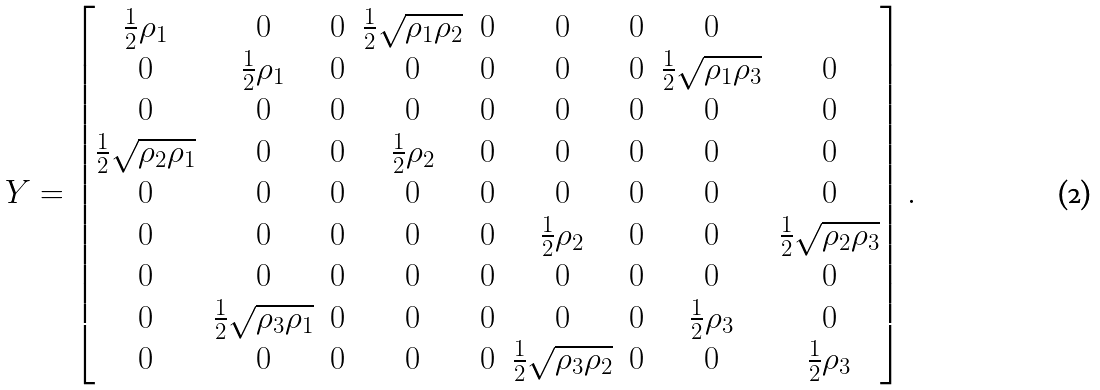Convert formula to latex. <formula><loc_0><loc_0><loc_500><loc_500>Y = \begin{bmatrix} \frac { 1 } { 2 } \rho _ { 1 } & 0 & 0 & \frac { 1 } { 2 } \sqrt { \rho _ { 1 } \rho _ { 2 } } & 0 & 0 & 0 & 0 & \\ 0 & \frac { 1 } { 2 } \rho _ { 1 } & 0 & 0 & 0 & 0 & 0 & \frac { 1 } { 2 } \sqrt { \rho _ { 1 } \rho _ { 3 } } & 0 \\ 0 & 0 & 0 & 0 & 0 & 0 & 0 & 0 & 0 \\ \frac { 1 } { 2 } \sqrt { \rho _ { 2 } \rho _ { 1 } } & 0 & 0 & \frac { 1 } { 2 } \rho _ { 2 } & 0 & 0 & 0 & 0 & 0 \\ 0 & 0 & 0 & 0 & 0 & 0 & 0 & 0 & 0 \\ 0 & 0 & 0 & 0 & 0 & \frac { 1 } { 2 } \rho _ { 2 } & 0 & 0 & \frac { 1 } { 2 } \sqrt { \rho _ { 2 } \rho _ { 3 } } \\ 0 & 0 & 0 & 0 & 0 & 0 & 0 & 0 & 0 \\ 0 & \frac { 1 } { 2 } \sqrt { \rho _ { 3 } \rho _ { 1 } } & 0 & 0 & 0 & 0 & 0 & \frac { 1 } { 2 } \rho _ { 3 } & 0 \\ 0 & 0 & 0 & 0 & 0 & \frac { 1 } { 2 } \sqrt { \rho _ { 3 } \rho _ { 2 } } & 0 & 0 & \frac { 1 } { 2 } \rho _ { 3 } \end{bmatrix} .</formula> 